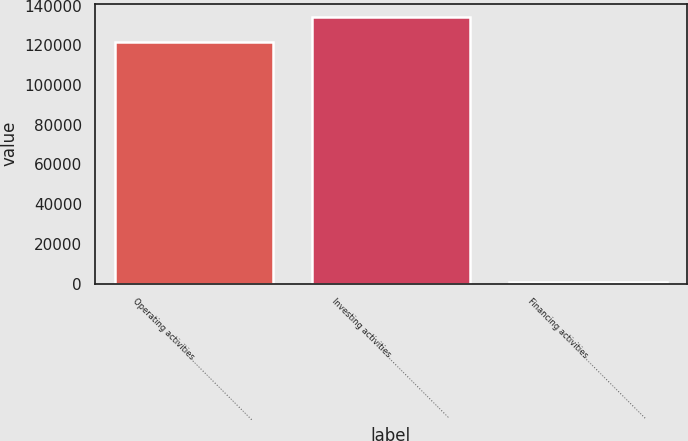Convert chart. <chart><loc_0><loc_0><loc_500><loc_500><bar_chart><fcel>Operating activities…………………………<fcel>Investing activities…………………………<fcel>Financing activities…………………………<nl><fcel>121738<fcel>134164<fcel>803<nl></chart> 